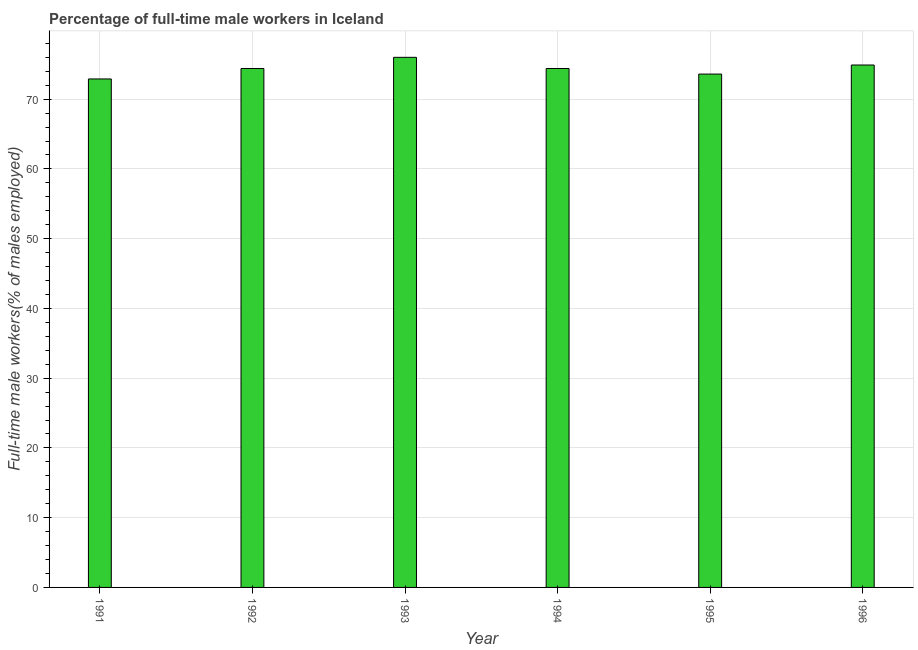Does the graph contain grids?
Your response must be concise. Yes. What is the title of the graph?
Offer a terse response. Percentage of full-time male workers in Iceland. What is the label or title of the X-axis?
Give a very brief answer. Year. What is the label or title of the Y-axis?
Give a very brief answer. Full-time male workers(% of males employed). What is the percentage of full-time male workers in 1994?
Keep it short and to the point. 74.4. Across all years, what is the minimum percentage of full-time male workers?
Your answer should be very brief. 72.9. In which year was the percentage of full-time male workers maximum?
Keep it short and to the point. 1993. What is the sum of the percentage of full-time male workers?
Your answer should be compact. 446.2. What is the average percentage of full-time male workers per year?
Ensure brevity in your answer.  74.37. What is the median percentage of full-time male workers?
Your answer should be very brief. 74.4. Do a majority of the years between 1991 and 1993 (inclusive) have percentage of full-time male workers greater than 4 %?
Give a very brief answer. Yes. Is the sum of the percentage of full-time male workers in 1992 and 1996 greater than the maximum percentage of full-time male workers across all years?
Your answer should be very brief. Yes. In how many years, is the percentage of full-time male workers greater than the average percentage of full-time male workers taken over all years?
Ensure brevity in your answer.  4. How many bars are there?
Keep it short and to the point. 6. How many years are there in the graph?
Make the answer very short. 6. What is the difference between two consecutive major ticks on the Y-axis?
Provide a short and direct response. 10. Are the values on the major ticks of Y-axis written in scientific E-notation?
Provide a succinct answer. No. What is the Full-time male workers(% of males employed) in 1991?
Your answer should be very brief. 72.9. What is the Full-time male workers(% of males employed) in 1992?
Give a very brief answer. 74.4. What is the Full-time male workers(% of males employed) in 1993?
Ensure brevity in your answer.  76. What is the Full-time male workers(% of males employed) in 1994?
Give a very brief answer. 74.4. What is the Full-time male workers(% of males employed) in 1995?
Keep it short and to the point. 73.6. What is the Full-time male workers(% of males employed) in 1996?
Offer a terse response. 74.9. What is the difference between the Full-time male workers(% of males employed) in 1991 and 1994?
Ensure brevity in your answer.  -1.5. What is the difference between the Full-time male workers(% of males employed) in 1991 and 1996?
Give a very brief answer. -2. What is the difference between the Full-time male workers(% of males employed) in 1992 and 1993?
Provide a succinct answer. -1.6. What is the difference between the Full-time male workers(% of males employed) in 1992 and 1995?
Offer a very short reply. 0.8. What is the difference between the Full-time male workers(% of males employed) in 1993 and 1995?
Your answer should be very brief. 2.4. What is the difference between the Full-time male workers(% of males employed) in 1993 and 1996?
Offer a very short reply. 1.1. What is the difference between the Full-time male workers(% of males employed) in 1995 and 1996?
Offer a very short reply. -1.3. What is the ratio of the Full-time male workers(% of males employed) in 1991 to that in 1993?
Ensure brevity in your answer.  0.96. What is the ratio of the Full-time male workers(% of males employed) in 1991 to that in 1995?
Your response must be concise. 0.99. What is the ratio of the Full-time male workers(% of males employed) in 1992 to that in 1996?
Keep it short and to the point. 0.99. What is the ratio of the Full-time male workers(% of males employed) in 1993 to that in 1995?
Keep it short and to the point. 1.03. What is the ratio of the Full-time male workers(% of males employed) in 1994 to that in 1995?
Ensure brevity in your answer.  1.01. What is the ratio of the Full-time male workers(% of males employed) in 1994 to that in 1996?
Your answer should be very brief. 0.99. What is the ratio of the Full-time male workers(% of males employed) in 1995 to that in 1996?
Your answer should be compact. 0.98. 